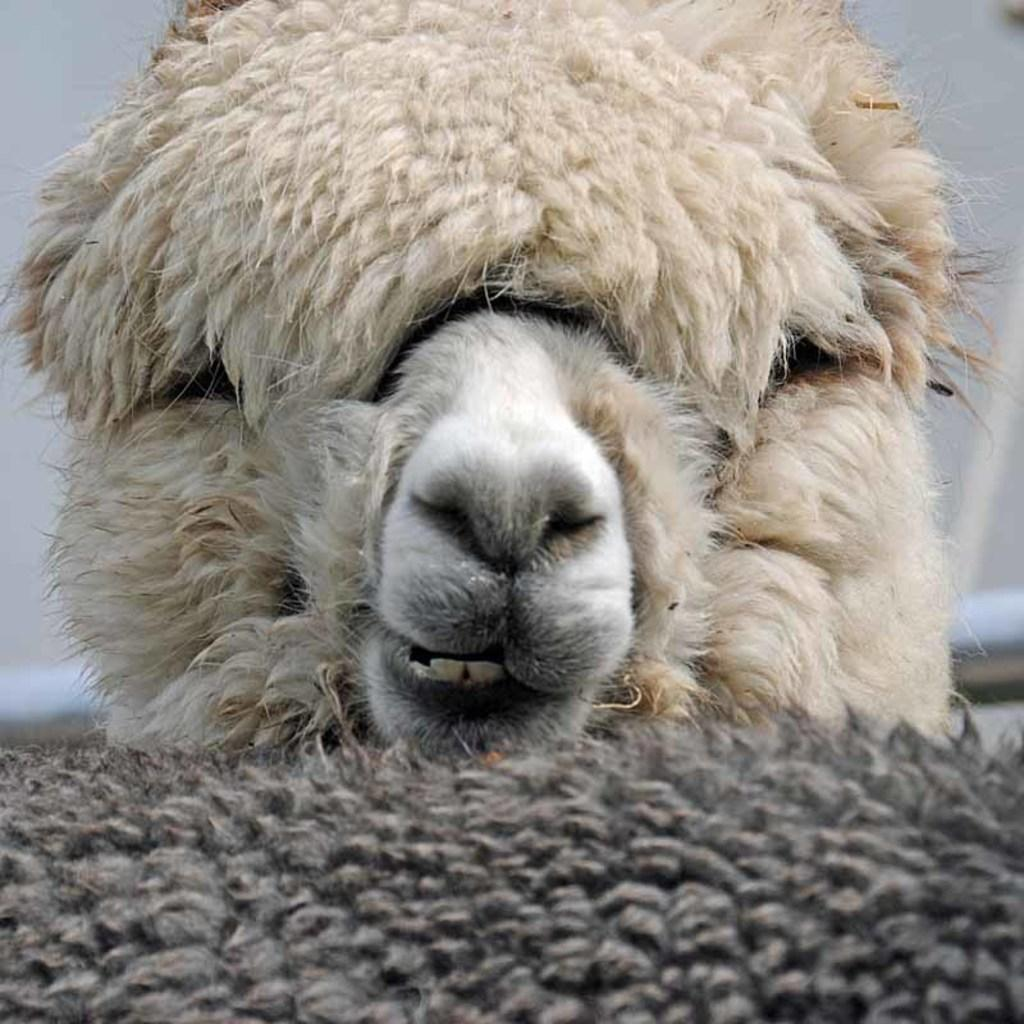What type of animal is in the image? There is an animal in the image, but its specific type cannot be determined from the provided facts. What colors can be seen on the animal? The animal has white, cream, and black colors. What is the color of the background in the image? The background of the image is white. How many cherries are on the goat's head in the image? There is no goat or cherries present in the image. 